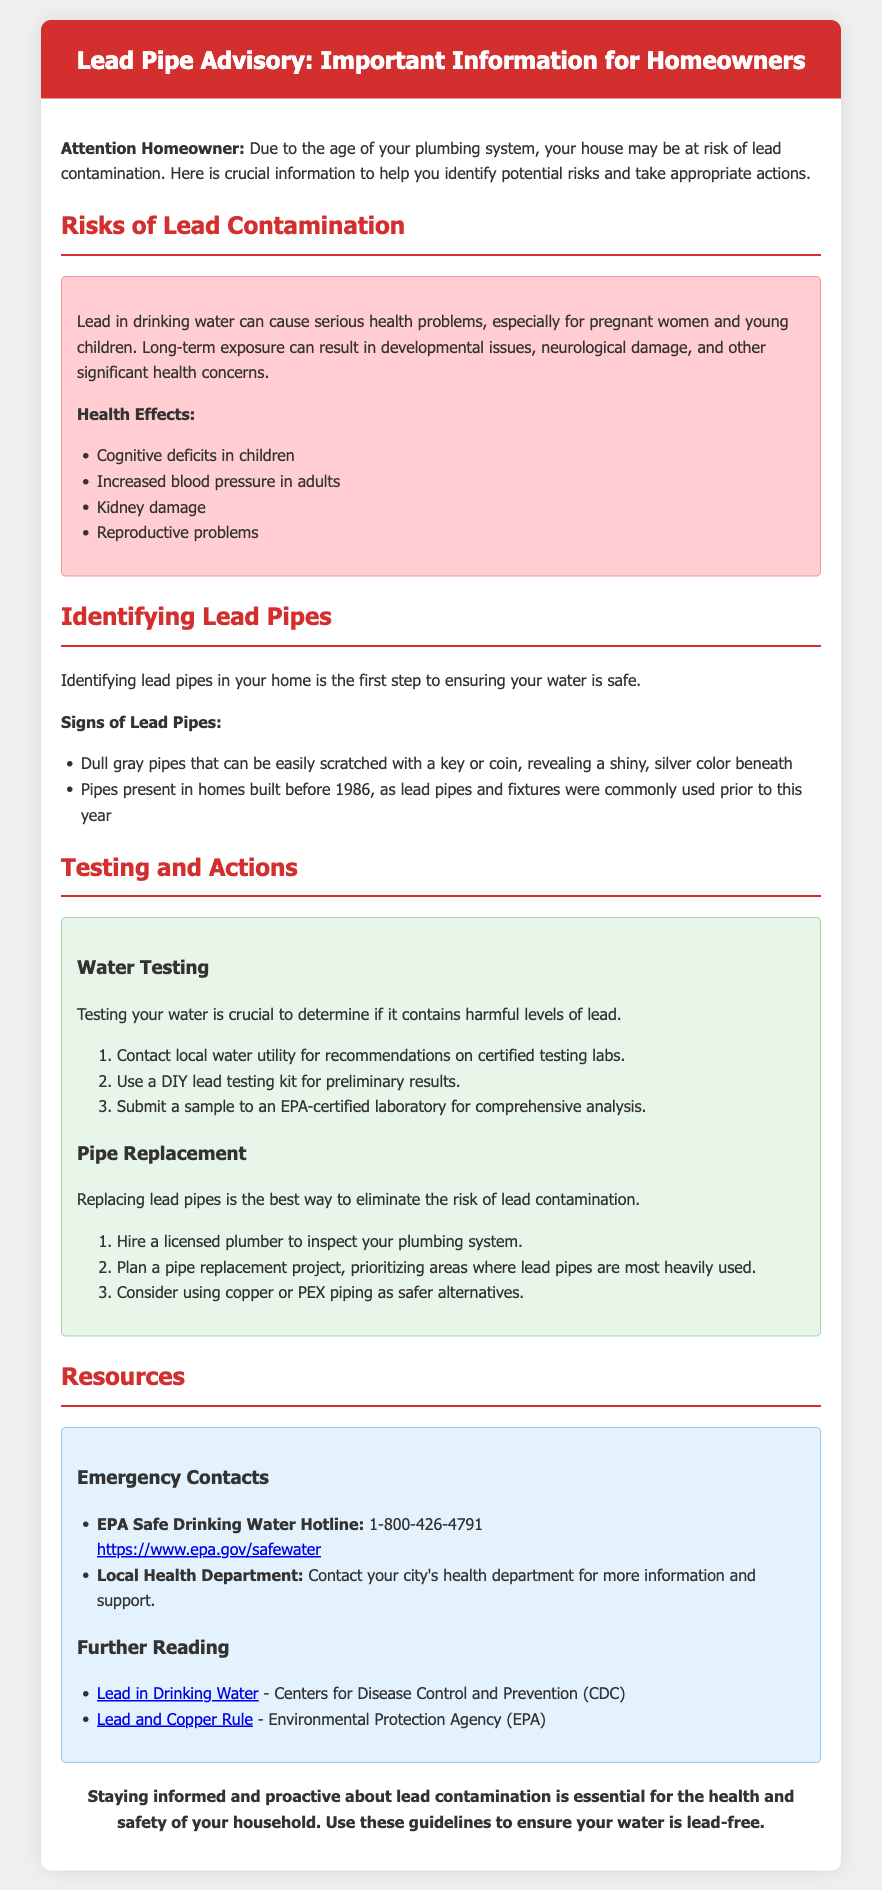What are the health effects of lead? The document lists the health effects of lead as cognitive deficits in children, increased blood pressure in adults, kidney damage, and reproductive problems.
Answer: Cognitive deficits in children, increased blood pressure in adults, kidney damage, reproductive problems When were lead pipes commonly used? The document states that lead pipes and fixtures were commonly used in homes built before 1986.
Answer: Before 1986 What should you do first if you suspect lead pipes? The document advises contacting a licensed plumber to inspect your plumbing system as the first step in addressing suspected lead pipes.
Answer: Hire a licensed plumber What is the telephone number for the EPA Safe Drinking Water Hotline? The hotline number is provided in the resources section of the document.
Answer: 1-800-426-4791 What are two methods for testing water for lead? According to the document, you can contact local water utility for recommendations on certified testing labs and use a DIY lead testing kit for preliminary results.
Answer: Contact local water utility, use a DIY lead testing kit What are alternative piping materials recommended for replacing lead pipes? The document suggests using safer alternatives like copper or PEX piping when replacing lead pipes.
Answer: Copper or PEX piping How serious can lead contamination be for children? The document mentions that lead can cause serious health problems, specifically cognitive deficits in children.
Answer: Cognitive deficits What is the conclusion about lead contamination awareness? The conclusion emphasizes the importance of staying informed and proactive about lead contamination for health and safety.
Answer: Staying informed and proactive 